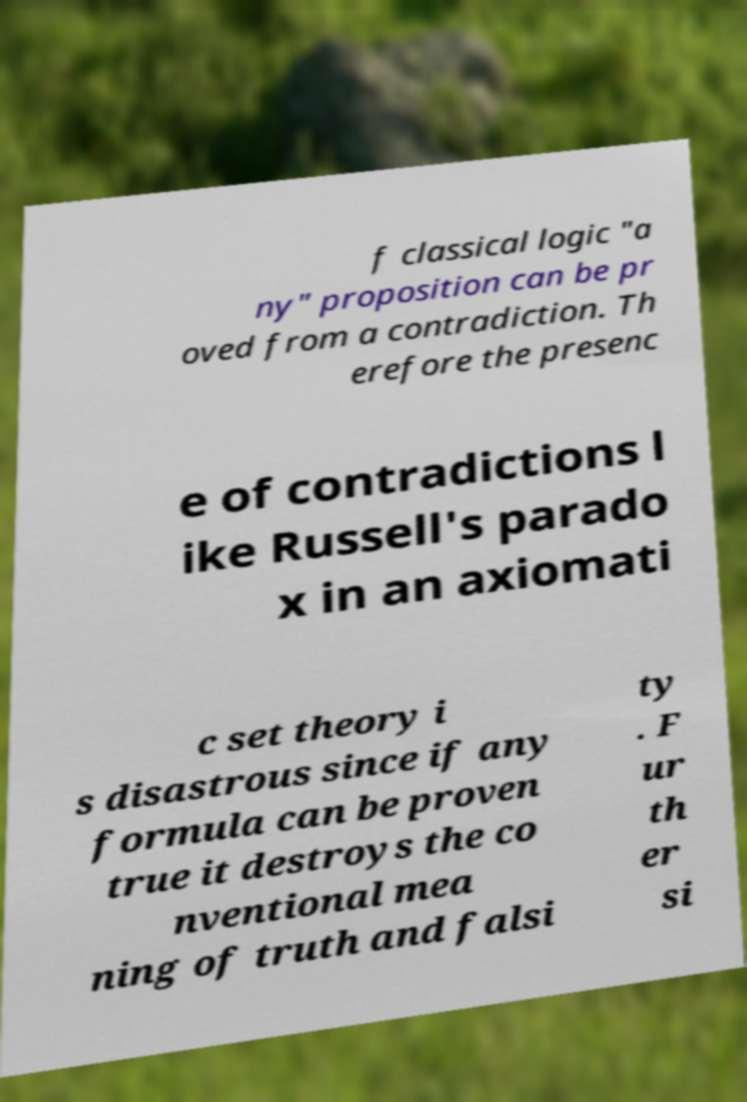Could you assist in decoding the text presented in this image and type it out clearly? f classical logic "a ny" proposition can be pr oved from a contradiction. Th erefore the presenc e of contradictions l ike Russell's parado x in an axiomati c set theory i s disastrous since if any formula can be proven true it destroys the co nventional mea ning of truth and falsi ty . F ur th er si 